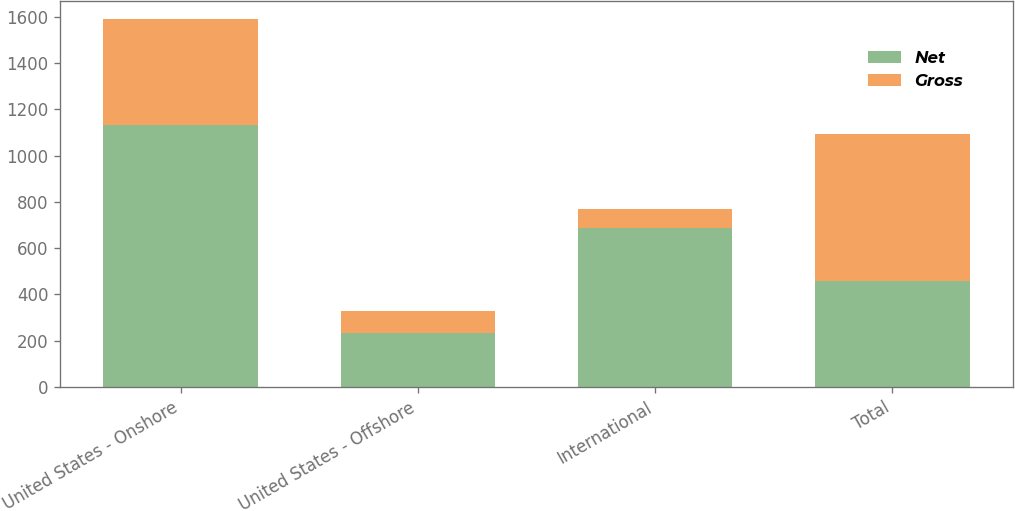<chart> <loc_0><loc_0><loc_500><loc_500><stacked_bar_chart><ecel><fcel>United States - Onshore<fcel>United States - Offshore<fcel>International<fcel>Total<nl><fcel>Net<fcel>1131<fcel>232.5<fcel>687<fcel>458.7<nl><fcel>Gross<fcel>458.7<fcel>95.7<fcel>81.3<fcel>635.7<nl></chart> 